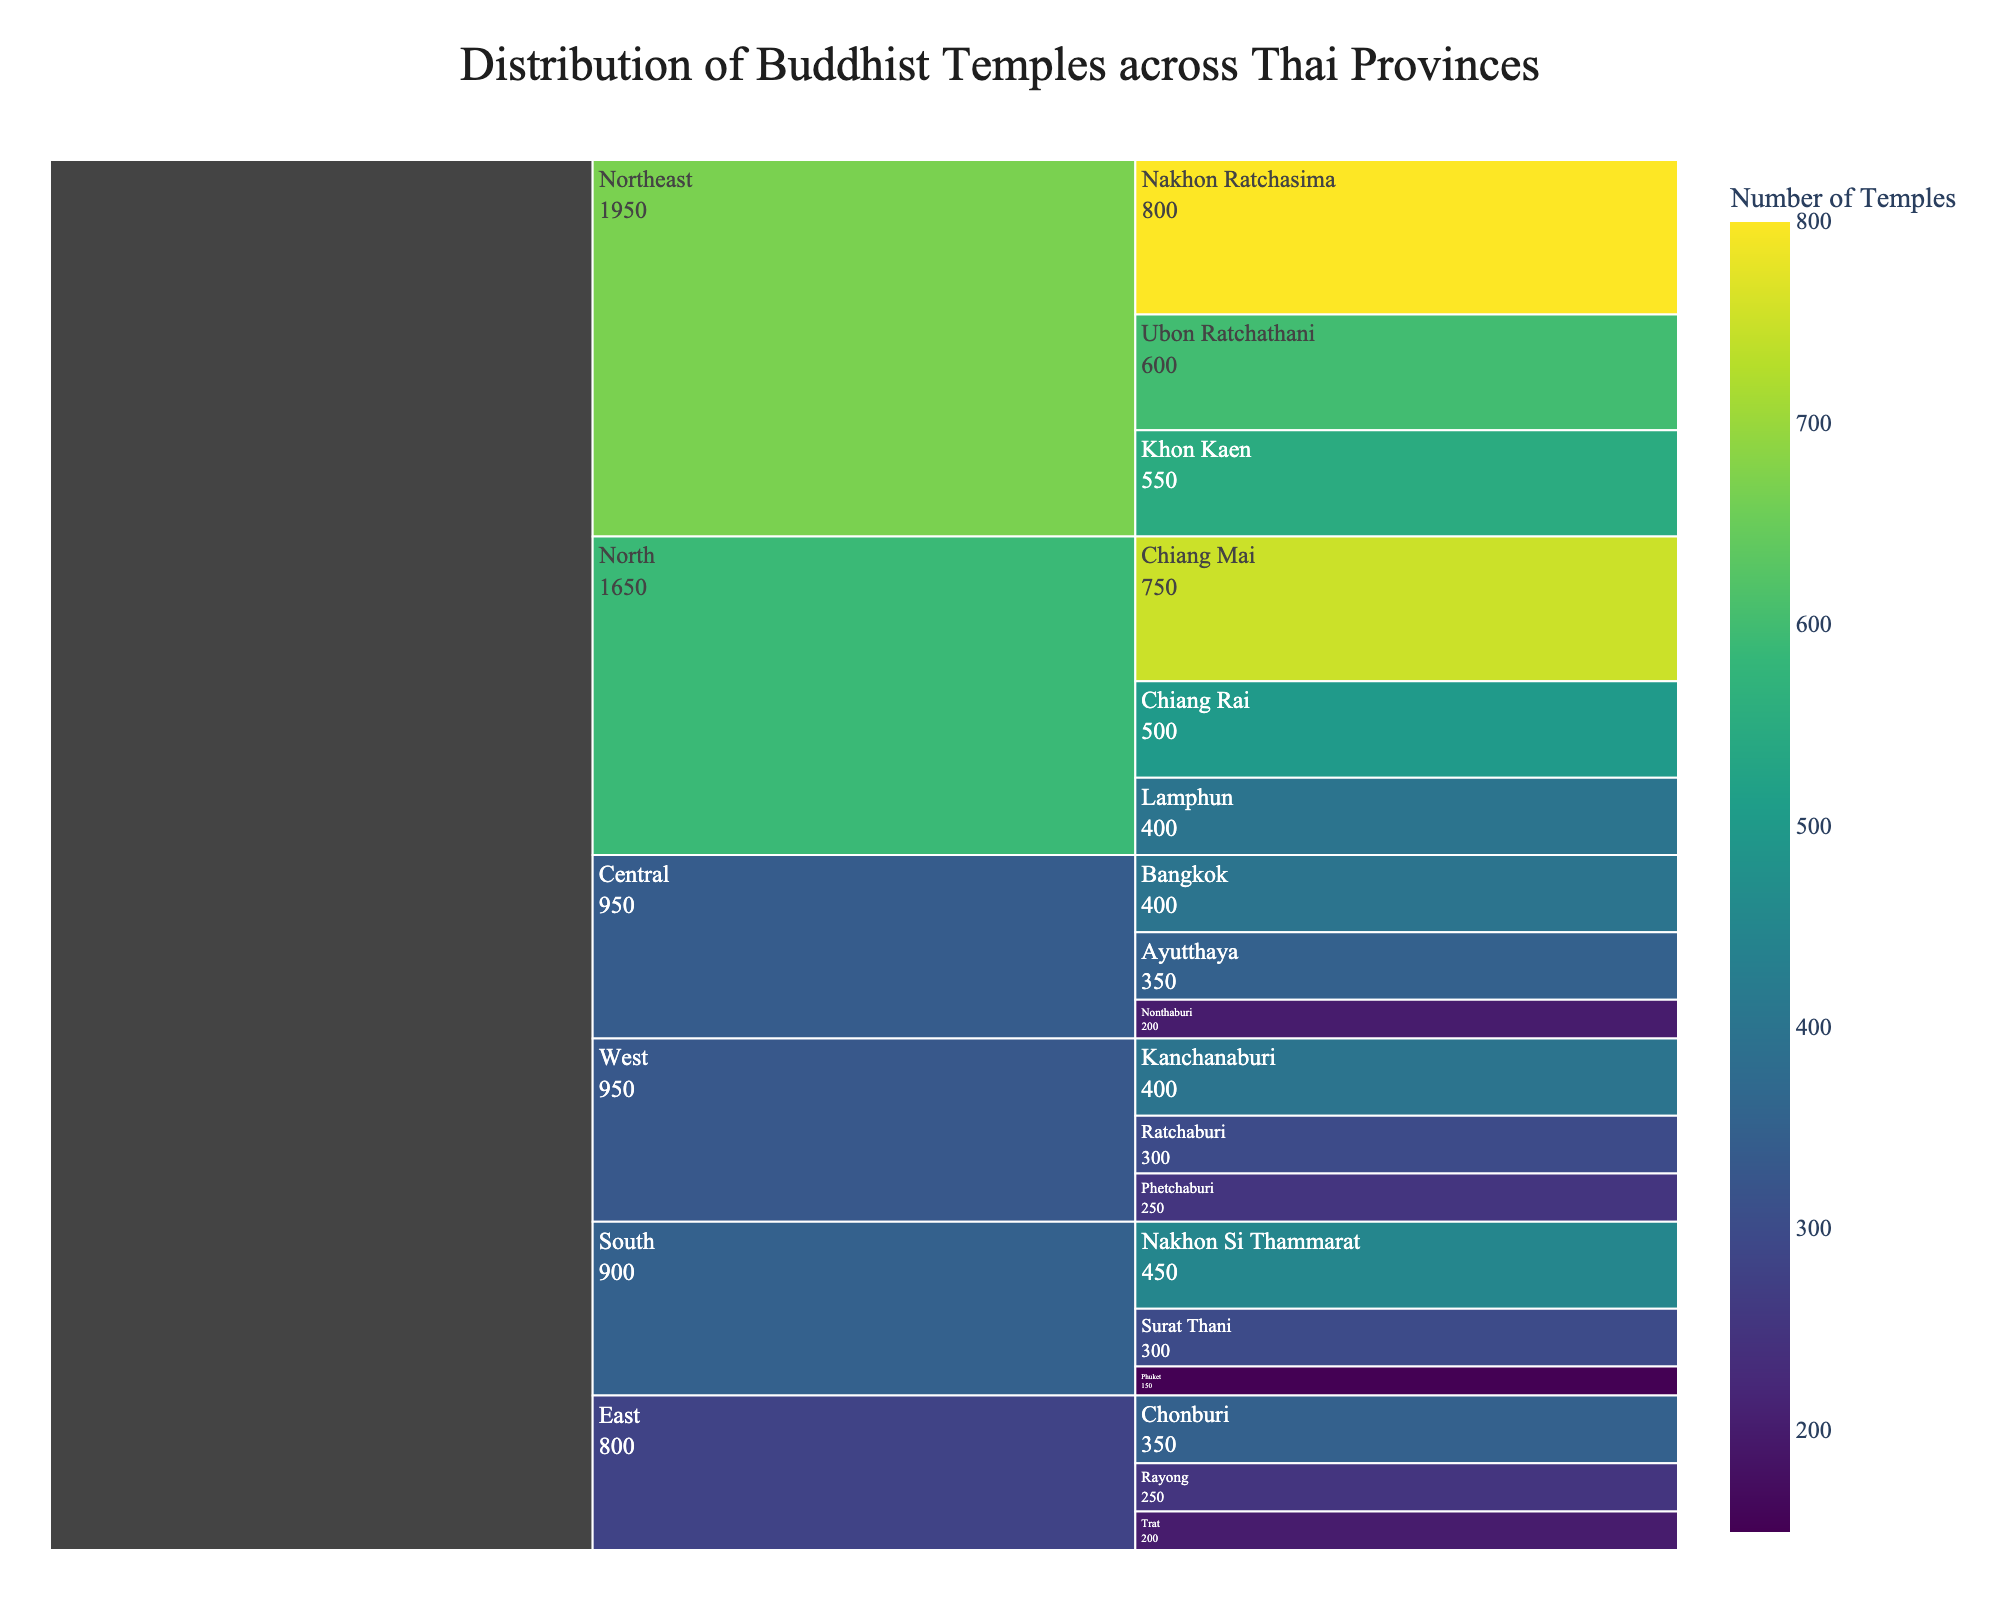How many regions are represented in the chart? The title "Distribution of Buddhist Temples across Thai Provinces" and the breakdown paths indicate that the chart shows regions. By counting the distinct regions, we find Central, North, Northeast, South, East, and West, making a total of 6 regions.
Answer: 6 Which province in the Northeast region has the highest number of temples? Within the Northeast region, comparing the figures, Nakhon Ratchasima has 800, Ubon Ratchathani has 600, and Khon Kaen has 550. Nakhon Ratchasima has the highest number.
Answer: Nakhon Ratchasima What is the total number of temples in the South region? Adding up the numbers for provinces in the South region: Surat Thani (300), Nakhon Si Thammarat (450), and Phuket (150): 300 + 450 + 150 = 900.
Answer: 900 Which province has the most Buddhist temples overall? By reviewing the chart, the province with the highest number is Nakhon Ratchasima in the Northeast with 800 temples.
Answer: Nakhon Ratchasima How does the number of temples in Bangkok compare to that in Chiang Mai? Bangkok (400) and Chiang Mai (750). Chiang Mai has a higher number than Bangkok.
Answer: Chiang Mai What is the average number of temples for the provinces in the Central region? Provinces in the Central region are Bangkok (400), Ayutthaya (350), and Nonthaburi (200). The average is (400 + 350 + 200) / 3 = 950 / 3 ≈ 316.67.
Answer: 316.67 Between the North and East regions, which has more temples in total? Summing up the North region: Chiang Mai (750), Chiang Rai (500), Lamphun (400) gives 750 + 500 + 400 = 1650. Summing up the East region: Chonburi (350), Rayong (250), Trat (200) gives 350 + 250 + 200 = 800. The North has more.
Answer: North Which region has the smallest average number of temples per province? Calculating averages for all regions: Central (950 / 3 ≈ 316.67), North (1650 / 3 ≈ 550), Northeast (1950 / 3 ≈ 650), South (900 / 3 ≈ 300), East (800 / 3 ≈ 266.67), West (950 / 3 ≈ 316.67). The East region has the smallest average.
Answer: East Is there any province in the West region with more temples than the average number of temples in the Central region? The Central region average is 316.67. In the West region, Kanchanaburi (400) and Ratchaburi (300) are compared: only Kanchanaburi (400) has more than 316.67.
Answer: Kanchanaburi 